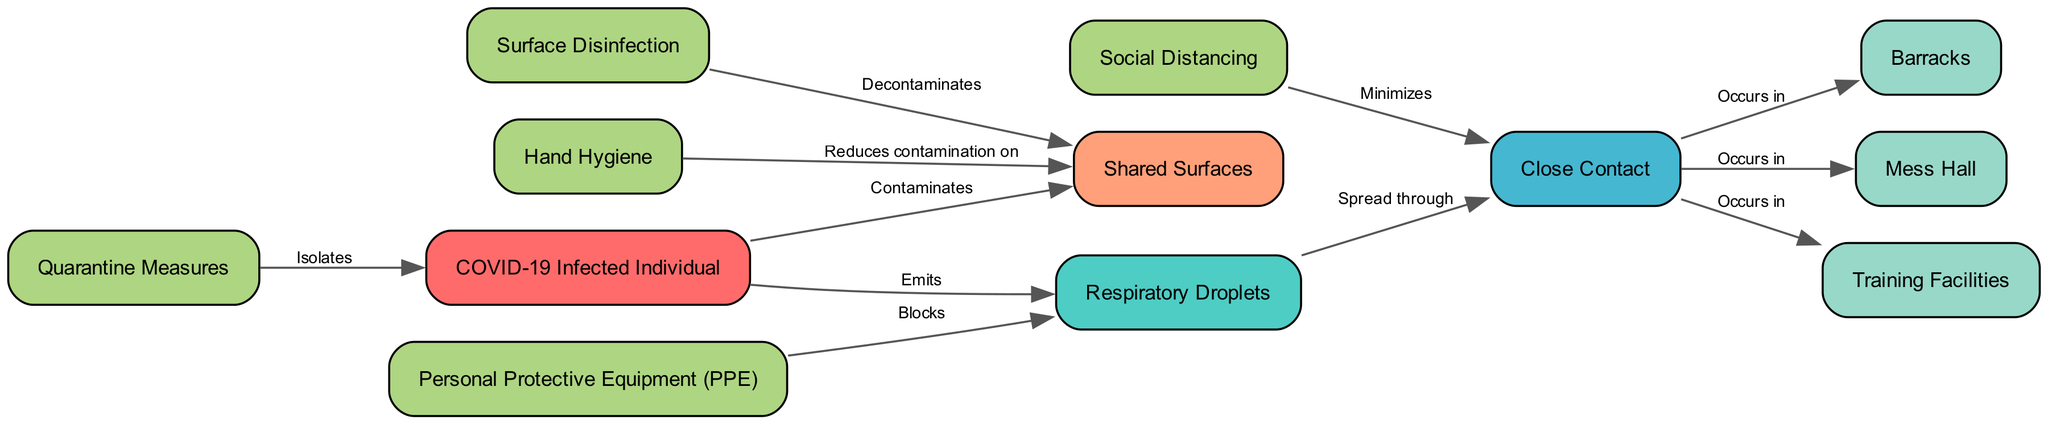What is the total number of nodes in the diagram? The diagram lists various entities involved in COVID-19 transmission and interventions, and counting them reveals there are 12 distinct nodes.
Answer: 12 What does a COVID-19 Infected Individual emit? According to the diagram, the arrows directed from the node "COVID-19 Infected Individual" to "Respiratory Droplets" indicate that they emit respiratory droplets.
Answer: Respiratory Droplets Which intervention minimizes close contact? The edge labeled "Minimizes" connects "Social Distancing" to "Close Contact," indicating that social distancing is an intervention that reduces instances of close contact.
Answer: Social Distancing How does Hand Hygiene affect Shared Surfaces? The diagram shows an edge from "Hand Hygiene" to "Shared Surfaces" labeled "Reduces contamination on," demonstrating that hand hygiene acts to decrease contamination on shared surfaces.
Answer: Reduces contamination on In which locations does Close Contact occur? The diagram has multiple edges indicating "Close Contact" occurs in "Barracks," "Mess Hall," and "Training Facilities." Therefore, these three locations are where close contact takes place.
Answer: Barracks, Mess Hall, Training Facilities What blocks respiratory droplets? The arrow from "Personal Protective Equipment (PPE)" to "Respiratory Droplets" marked "Blocks" indicates that PPE is the intervention that obstructs the transmission of respiratory droplets.
Answer: Personal Protective Equipment (PPE) What action do quarantine measures perform? The edge from "Quarantine Measures" to "COVID-19 Infected Individual" is labeled "Isolates," meaning that quarantine measures isolate individuals who are infected with COVID-19.
Answer: Isolates What decontaminates shared surfaces? There is a directed edge from "Surface Disinfection" to "Shared Surfaces" labeled "Decontaminates," showing that surface disinfection is the action taken to clean and remove contaminants from shared surfaces.
Answer: Decontaminates Which intervention is shown to occur in multiple locations? The "Close Contact" node has edges labeled "Occurs in" leading to "Barracks," "Mess Hall," and "Training Facilities," demonstrating that this type of interaction takes place in several military settings.
Answer: Barracks, Mess Hall, Training Facilities 